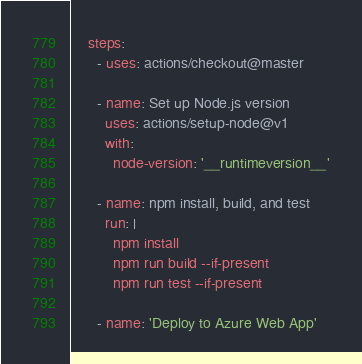<code> <loc_0><loc_0><loc_500><loc_500><_YAML_>    steps:
      - uses: actions/checkout@master

      - name: Set up Node.js version
        uses: actions/setup-node@v1
        with:
          node-version: '__runtimeversion__'

      - name: npm install, build, and test
        run: |
          npm install
          npm run build --if-present
          npm run test --if-present

      - name: 'Deploy to Azure Web App'</code> 